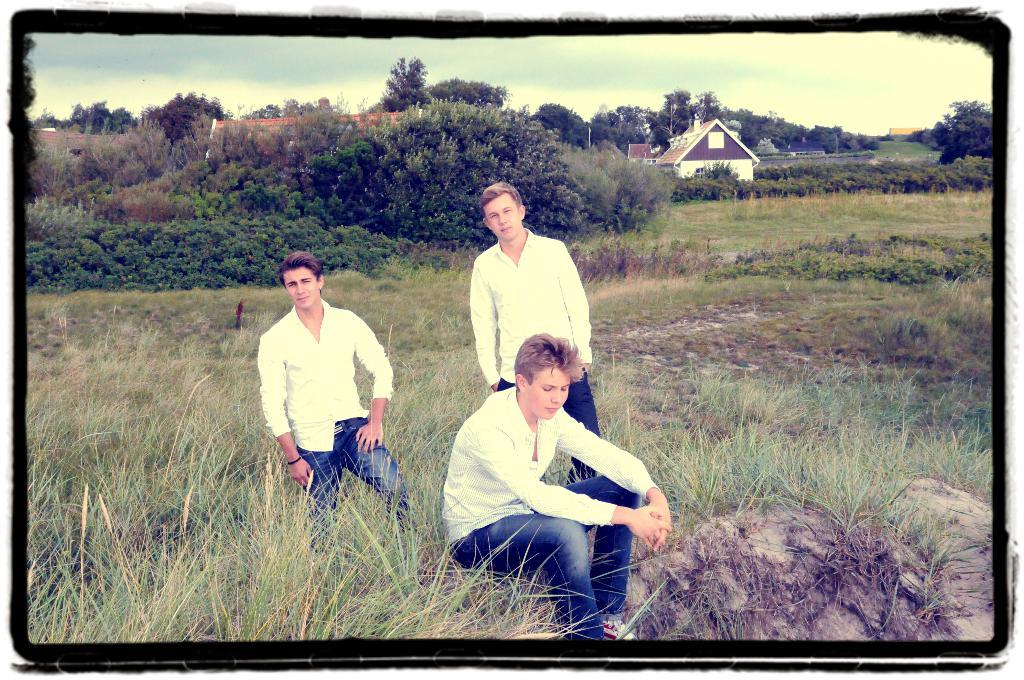How many people are in the image? There are three persons in the image. What are the positions of the people in the image? One person is sitting on a rock, and two persons are standing. What type of vegetation can be seen in the image? There are plants, grass, and trees in the image. What type of structures are visible in the image? There are houses and poles in the image. What is visible in the background of the image? The sky is visible in the background of the image. What type of pest can be seen crawling on the person sitting on the rock? There is no pest visible on the person sitting on the rock in the image. What type of lock is holding the poles together in the image? There are no locks visible in the image; the poles are not connected to each other. 